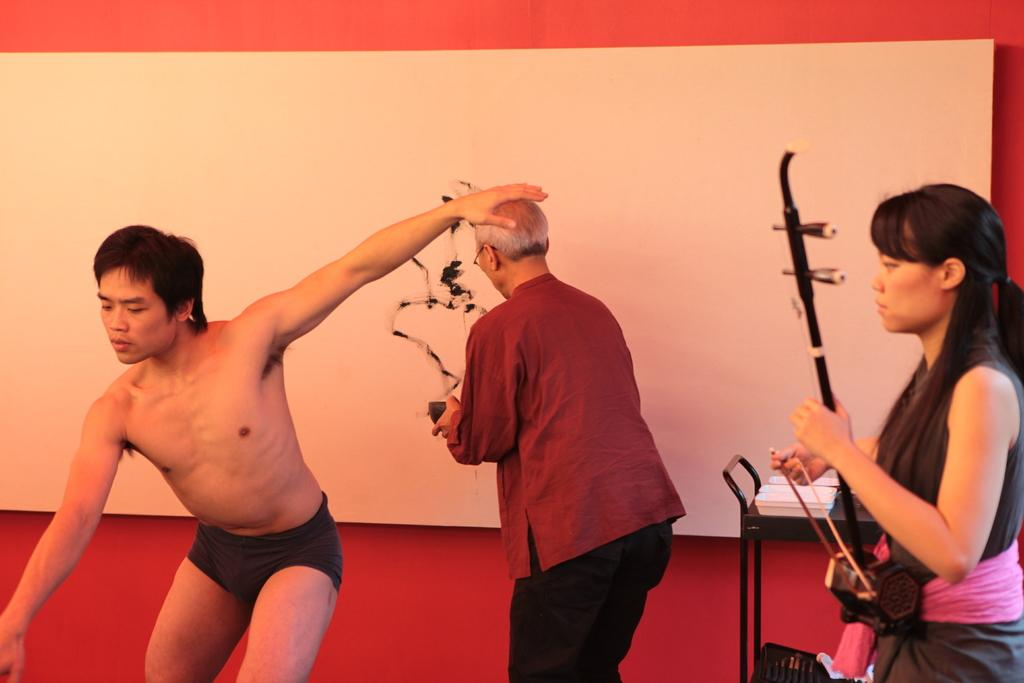How many people are present in the image? There are three people in the image: a woman, a man, and an old man. What objects can be seen on the desk in the image? There are plates on the desk in the image. What is the background of the image? There is a well in the background of the image. What type of collar can be seen on the old man in the image? There is no collar visible on the old man in the image. Is the well in the background of the image square-shaped? The shape of the well in the background of the image is not mentioned in the provided facts, so it cannot be determined from the image. 